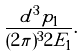Convert formula to latex. <formula><loc_0><loc_0><loc_500><loc_500>\frac { d ^ { 3 } p _ { 1 } } { ( 2 \pi ) ^ { 3 } 2 E _ { 1 } } .</formula> 